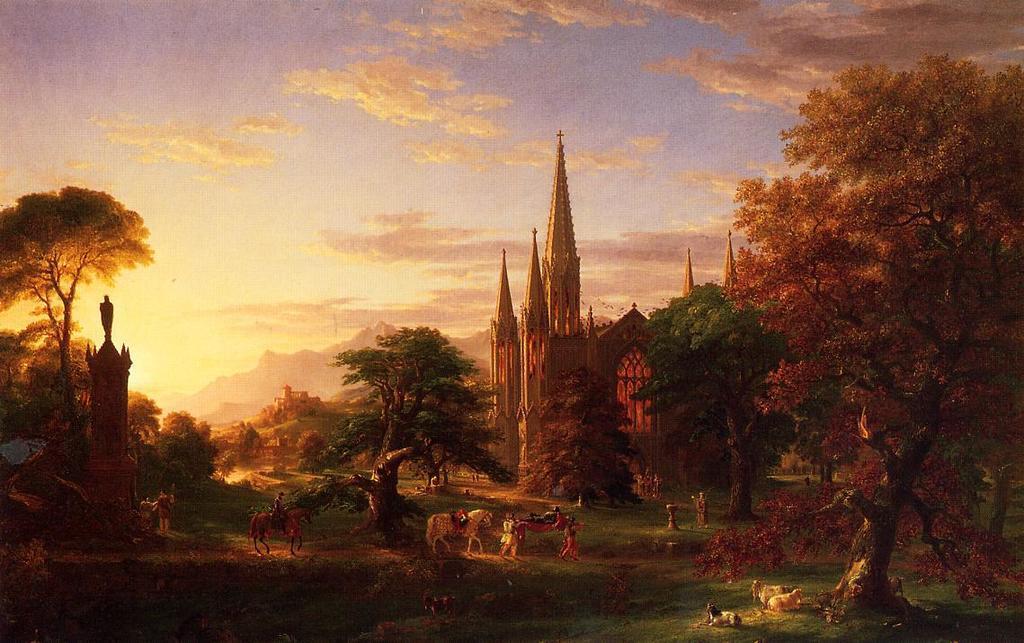Please provide a concise description of this image. In this image I can see animals, people, castles, trees, mountains, grass and cloudy sky. 